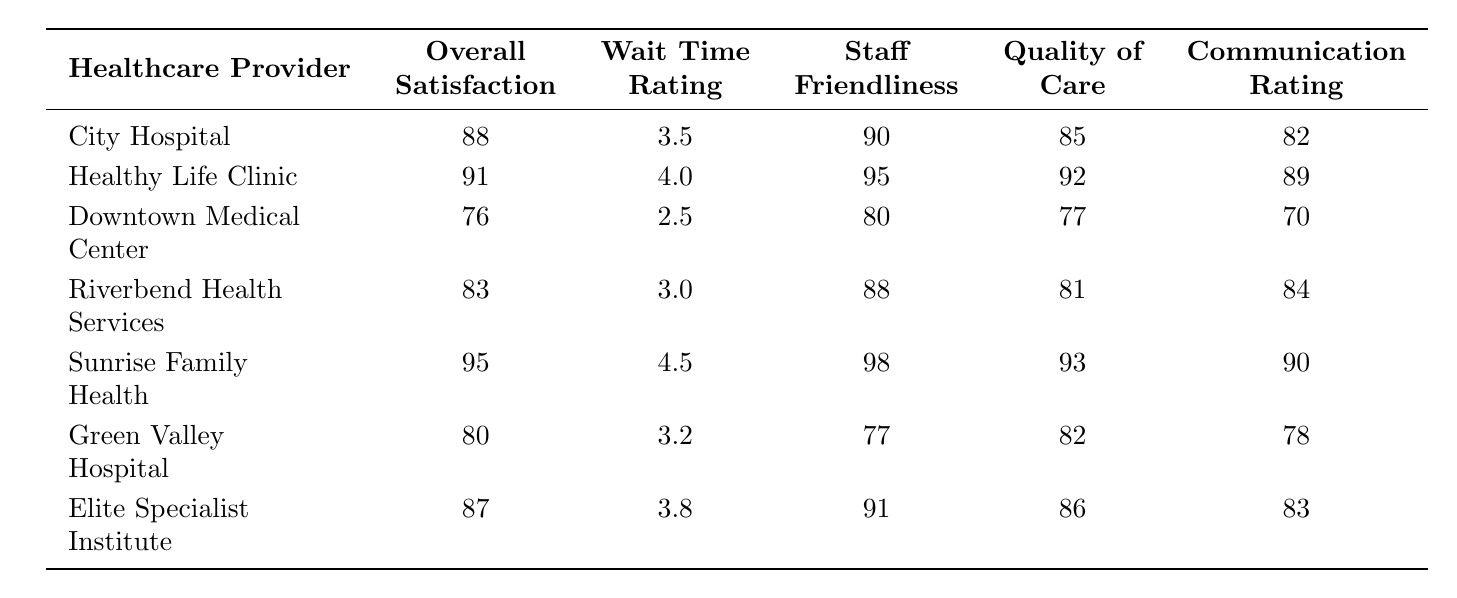What is the Overall Satisfaction rating for Sunrise Family Health? The table shows that the Overall Satisfaction rating for Sunrise Family Health is directly listed as 95.
Answer: 95 Which healthcare provider has the highest Staff Friendliness rating? By comparing the values in the Staff Friendliness column, Sunrise Family Health has the highest rating at 98.
Answer: Sunrise Family Health What is the average Wait Time Rating for all healthcare providers? To calculate the average, we sum the Wait Time Ratings (3.5 + 4.0 + 2.5 + 3.0 + 4.5 + 3.2 + 3.8 = 24.5) and divide by the number of providers (7): 24.5 / 7 ≈ 3.50.
Answer: 3.50 Is the Communication Rating for Downtown Medical Center over 75? The Communication Rating for Downtown Medical Center is 70, which is not over 75.
Answer: No What is the difference in Overall Satisfaction between Healthy Life Clinic and Downtown Medical Center? The Overall Satisfaction for Healthy Life Clinic is 91 and for Downtown Medical Center is 76. The difference is calculated as 91 - 76 = 15.
Answer: 15 Which healthcare provider ranked lowest in Quality of Care? By checking the Quality of Care column, Downtown Medical Center has the lowest rating at 77.
Answer: Downtown Medical Center If we consider only the providers with Overall Satisfaction above 85, what is the average Staff Friendliness rating for those providers? The relevant providers are Sunrise Family Health, Healthy Life Clinic, City Hospital, and Elite Specialist Institute. Their Staff Friendliness ratings are 98, 95, 90, and 91. The average is (98 + 95 + 90 + 91) / 4 = 93.5.
Answer: 93.5 How many healthcare providers have a Wait Time Rating of 4.0 or higher? The providers with a Wait Time Rating of 4.0 or higher are Healthy Life Clinic and Sunrise Family Health, totaling 2 providers.
Answer: 2 What is the highest Communication Rating among the surveyed healthcare providers? The highest Communication Rating can be found in the table, which is 90 for Sunrise Family Health.
Answer: 90 How does the Overall Satisfaction rating of Green Valley Hospital compare to that of Elite Specialist Institute? Green Valley Hospital has an Overall Satisfaction rating of 80, while Elite Specialist Institute has a rating of 87. Thus, Elite Specialist Institute is higher by 7 points (87 - 80 = 7).
Answer: Elite Specialist Institute is higher by 7 points 